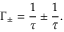<formula> <loc_0><loc_0><loc_500><loc_500>\Gamma _ { \pm } = \frac { 1 } { \tau } \pm \frac { 1 } { \bar { \tau } } .</formula> 